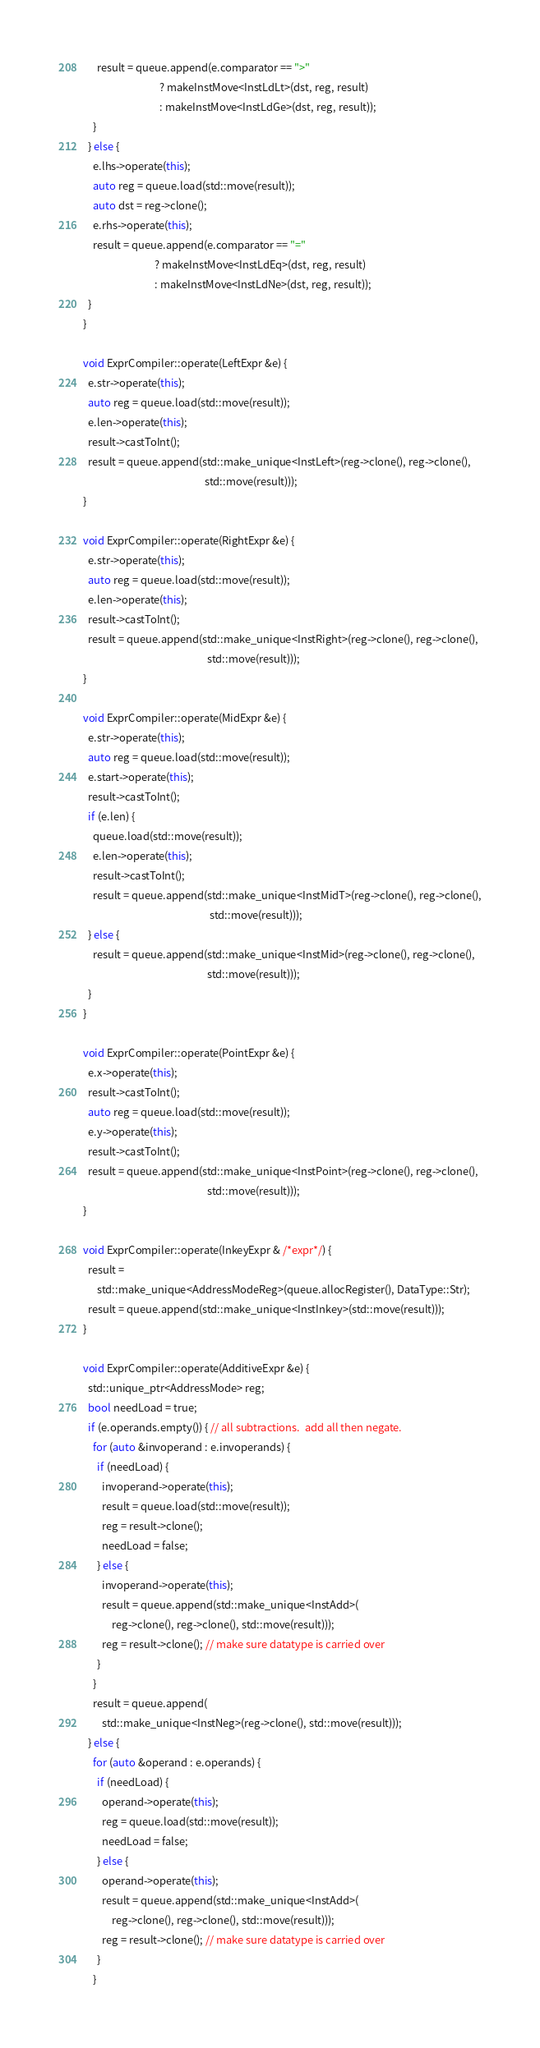Convert code to text. <code><loc_0><loc_0><loc_500><loc_500><_C++_>      result = queue.append(e.comparator == ">"
                                ? makeInstMove<InstLdLt>(dst, reg, result)
                                : makeInstMove<InstLdGe>(dst, reg, result));
    }
  } else {
    e.lhs->operate(this);
    auto reg = queue.load(std::move(result));
    auto dst = reg->clone();
    e.rhs->operate(this);
    result = queue.append(e.comparator == "="
                              ? makeInstMove<InstLdEq>(dst, reg, result)
                              : makeInstMove<InstLdNe>(dst, reg, result));
  }
}

void ExprCompiler::operate(LeftExpr &e) {
  e.str->operate(this);
  auto reg = queue.load(std::move(result));
  e.len->operate(this);
  result->castToInt();
  result = queue.append(std::make_unique<InstLeft>(reg->clone(), reg->clone(),
                                                   std::move(result)));
}

void ExprCompiler::operate(RightExpr &e) {
  e.str->operate(this);
  auto reg = queue.load(std::move(result));
  e.len->operate(this);
  result->castToInt();
  result = queue.append(std::make_unique<InstRight>(reg->clone(), reg->clone(),
                                                    std::move(result)));
}

void ExprCompiler::operate(MidExpr &e) {
  e.str->operate(this);
  auto reg = queue.load(std::move(result));
  e.start->operate(this);
  result->castToInt();
  if (e.len) {
    queue.load(std::move(result));
    e.len->operate(this);
    result->castToInt();
    result = queue.append(std::make_unique<InstMidT>(reg->clone(), reg->clone(),
                                                     std::move(result)));
  } else {
    result = queue.append(std::make_unique<InstMid>(reg->clone(), reg->clone(),
                                                    std::move(result)));
  }
}

void ExprCompiler::operate(PointExpr &e) {
  e.x->operate(this);
  result->castToInt();
  auto reg = queue.load(std::move(result));
  e.y->operate(this);
  result->castToInt();
  result = queue.append(std::make_unique<InstPoint>(reg->clone(), reg->clone(),
                                                    std::move(result)));
}

void ExprCompiler::operate(InkeyExpr & /*expr*/) {
  result =
      std::make_unique<AddressModeReg>(queue.allocRegister(), DataType::Str);
  result = queue.append(std::make_unique<InstInkey>(std::move(result)));
}

void ExprCompiler::operate(AdditiveExpr &e) {
  std::unique_ptr<AddressMode> reg;
  bool needLoad = true;
  if (e.operands.empty()) { // all subtractions.  add all then negate.
    for (auto &invoperand : e.invoperands) {
      if (needLoad) {
        invoperand->operate(this);
        result = queue.load(std::move(result));
        reg = result->clone();
        needLoad = false;
      } else {
        invoperand->operate(this);
        result = queue.append(std::make_unique<InstAdd>(
            reg->clone(), reg->clone(), std::move(result)));
        reg = result->clone(); // make sure datatype is carried over
      }
    }
    result = queue.append(
        std::make_unique<InstNeg>(reg->clone(), std::move(result)));
  } else {
    for (auto &operand : e.operands) {
      if (needLoad) {
        operand->operate(this);
        reg = queue.load(std::move(result));
        needLoad = false;
      } else {
        operand->operate(this);
        result = queue.append(std::make_unique<InstAdd>(
            reg->clone(), reg->clone(), std::move(result)));
        reg = result->clone(); // make sure datatype is carried over
      }
    }</code> 